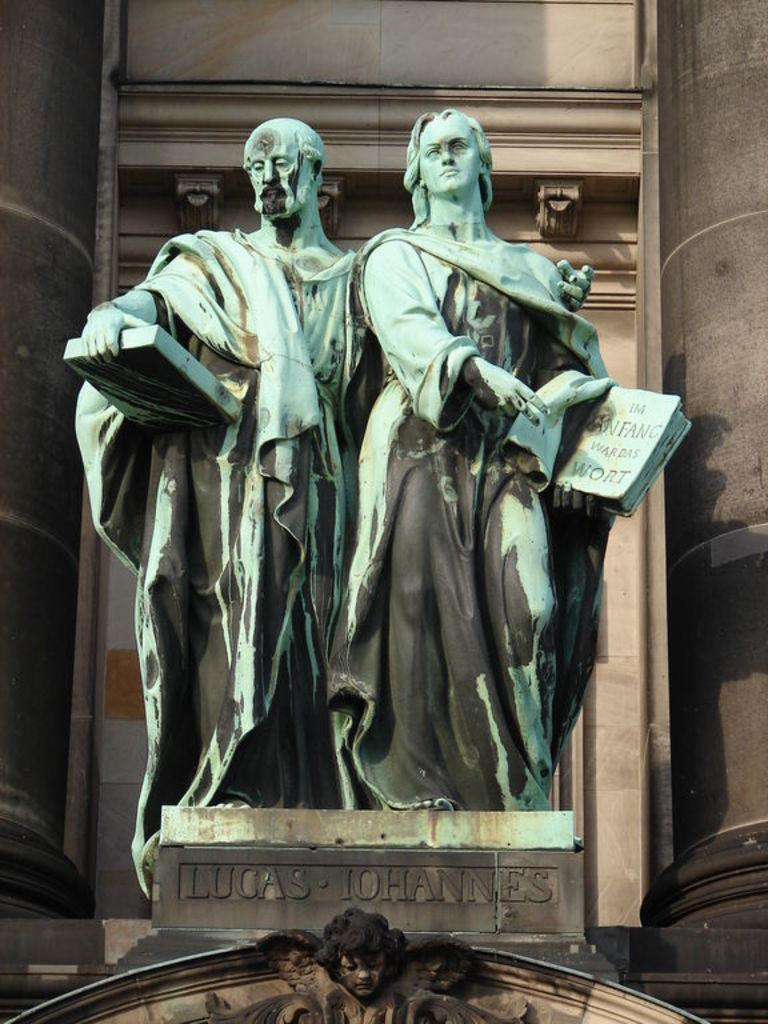What is depicted on the stone in the image? There are two person sculptures on a stone in the image. What material are the sculptures made of? The sculptures are made of stone. What can be seen behind the stone in the image? There is a wall behind the stone in the image. What color is the wall? The wall is cream in color. What name is written on the stone? The name "LUCAS JOHNNIE" is written on the stone. What type of quilt is being used to cover the sculptures in the image? There is no quilt present in the image; the sculptures are made of stone and are not covered by any fabric. 